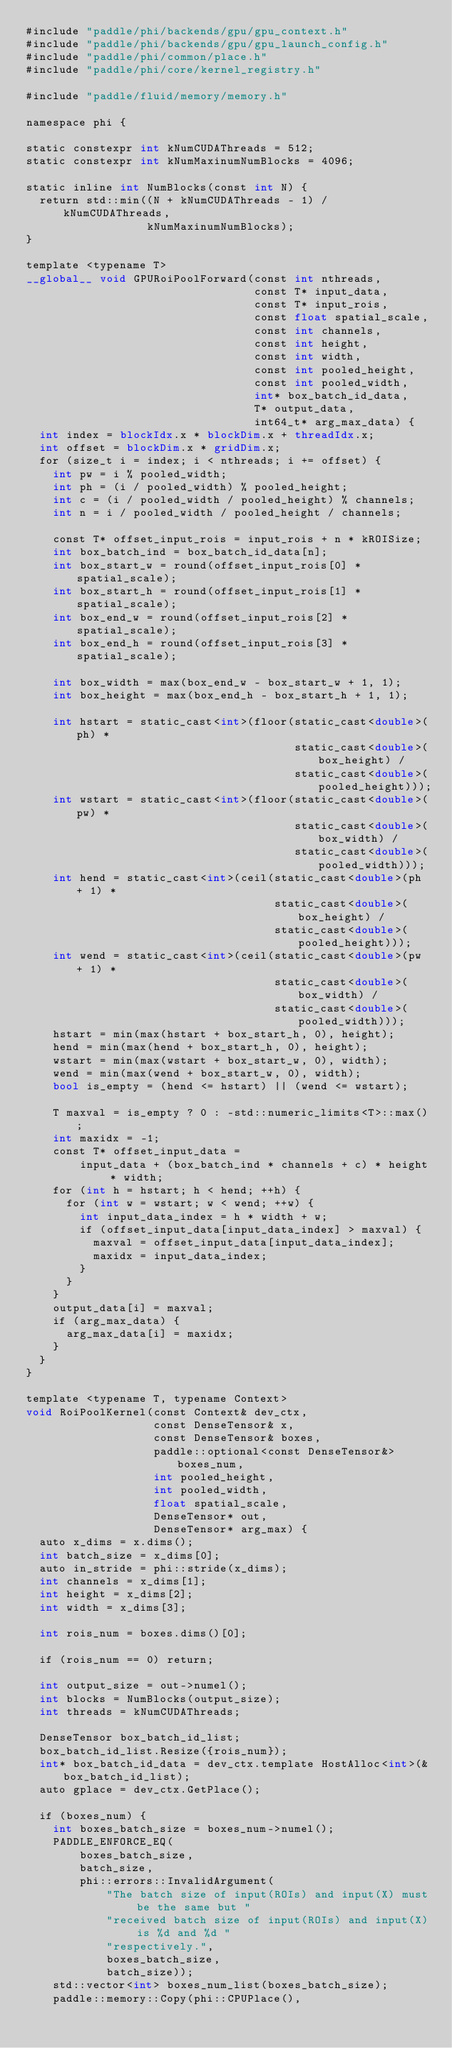Convert code to text. <code><loc_0><loc_0><loc_500><loc_500><_Cuda_>#include "paddle/phi/backends/gpu/gpu_context.h"
#include "paddle/phi/backends/gpu/gpu_launch_config.h"
#include "paddle/phi/common/place.h"
#include "paddle/phi/core/kernel_registry.h"

#include "paddle/fluid/memory/memory.h"

namespace phi {

static constexpr int kNumCUDAThreads = 512;
static constexpr int kNumMaxinumNumBlocks = 4096;

static inline int NumBlocks(const int N) {
  return std::min((N + kNumCUDAThreads - 1) / kNumCUDAThreads,
                  kNumMaxinumNumBlocks);
}

template <typename T>
__global__ void GPURoiPoolForward(const int nthreads,
                                  const T* input_data,
                                  const T* input_rois,
                                  const float spatial_scale,
                                  const int channels,
                                  const int height,
                                  const int width,
                                  const int pooled_height,
                                  const int pooled_width,
                                  int* box_batch_id_data,
                                  T* output_data,
                                  int64_t* arg_max_data) {
  int index = blockIdx.x * blockDim.x + threadIdx.x;
  int offset = blockDim.x * gridDim.x;
  for (size_t i = index; i < nthreads; i += offset) {
    int pw = i % pooled_width;
    int ph = (i / pooled_width) % pooled_height;
    int c = (i / pooled_width / pooled_height) % channels;
    int n = i / pooled_width / pooled_height / channels;

    const T* offset_input_rois = input_rois + n * kROISize;
    int box_batch_ind = box_batch_id_data[n];
    int box_start_w = round(offset_input_rois[0] * spatial_scale);
    int box_start_h = round(offset_input_rois[1] * spatial_scale);
    int box_end_w = round(offset_input_rois[2] * spatial_scale);
    int box_end_h = round(offset_input_rois[3] * spatial_scale);

    int box_width = max(box_end_w - box_start_w + 1, 1);
    int box_height = max(box_end_h - box_start_h + 1, 1);

    int hstart = static_cast<int>(floor(static_cast<double>(ph) *
                                        static_cast<double>(box_height) /
                                        static_cast<double>(pooled_height)));
    int wstart = static_cast<int>(floor(static_cast<double>(pw) *
                                        static_cast<double>(box_width) /
                                        static_cast<double>(pooled_width)));
    int hend = static_cast<int>(ceil(static_cast<double>(ph + 1) *
                                     static_cast<double>(box_height) /
                                     static_cast<double>(pooled_height)));
    int wend = static_cast<int>(ceil(static_cast<double>(pw + 1) *
                                     static_cast<double>(box_width) /
                                     static_cast<double>(pooled_width)));
    hstart = min(max(hstart + box_start_h, 0), height);
    hend = min(max(hend + box_start_h, 0), height);
    wstart = min(max(wstart + box_start_w, 0), width);
    wend = min(max(wend + box_start_w, 0), width);
    bool is_empty = (hend <= hstart) || (wend <= wstart);

    T maxval = is_empty ? 0 : -std::numeric_limits<T>::max();
    int maxidx = -1;
    const T* offset_input_data =
        input_data + (box_batch_ind * channels + c) * height * width;
    for (int h = hstart; h < hend; ++h) {
      for (int w = wstart; w < wend; ++w) {
        int input_data_index = h * width + w;
        if (offset_input_data[input_data_index] > maxval) {
          maxval = offset_input_data[input_data_index];
          maxidx = input_data_index;
        }
      }
    }
    output_data[i] = maxval;
    if (arg_max_data) {
      arg_max_data[i] = maxidx;
    }
  }
}

template <typename T, typename Context>
void RoiPoolKernel(const Context& dev_ctx,
                   const DenseTensor& x,
                   const DenseTensor& boxes,
                   paddle::optional<const DenseTensor&> boxes_num,
                   int pooled_height,
                   int pooled_width,
                   float spatial_scale,
                   DenseTensor* out,
                   DenseTensor* arg_max) {
  auto x_dims = x.dims();
  int batch_size = x_dims[0];
  auto in_stride = phi::stride(x_dims);
  int channels = x_dims[1];
  int height = x_dims[2];
  int width = x_dims[3];

  int rois_num = boxes.dims()[0];

  if (rois_num == 0) return;

  int output_size = out->numel();
  int blocks = NumBlocks(output_size);
  int threads = kNumCUDAThreads;

  DenseTensor box_batch_id_list;
  box_batch_id_list.Resize({rois_num});
  int* box_batch_id_data = dev_ctx.template HostAlloc<int>(&box_batch_id_list);
  auto gplace = dev_ctx.GetPlace();

  if (boxes_num) {
    int boxes_batch_size = boxes_num->numel();
    PADDLE_ENFORCE_EQ(
        boxes_batch_size,
        batch_size,
        phi::errors::InvalidArgument(
            "The batch size of input(ROIs) and input(X) must be the same but "
            "received batch size of input(ROIs) and input(X) is %d and %d "
            "respectively.",
            boxes_batch_size,
            batch_size));
    std::vector<int> boxes_num_list(boxes_batch_size);
    paddle::memory::Copy(phi::CPUPlace(),</code> 